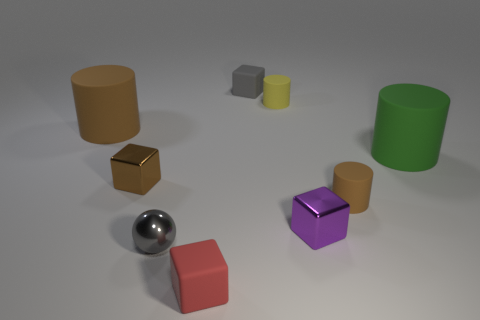Subtract all large brown cylinders. How many cylinders are left? 3 Subtract 1 balls. How many balls are left? 0 Subtract all purple blocks. How many blocks are left? 3 Subtract all cyan cubes. How many brown cylinders are left? 2 Add 1 shiny objects. How many objects exist? 10 Subtract all cylinders. How many objects are left? 5 Subtract 1 gray balls. How many objects are left? 8 Subtract all brown blocks. Subtract all purple balls. How many blocks are left? 3 Subtract all big red matte things. Subtract all small brown cubes. How many objects are left? 8 Add 4 tiny red cubes. How many tiny red cubes are left? 5 